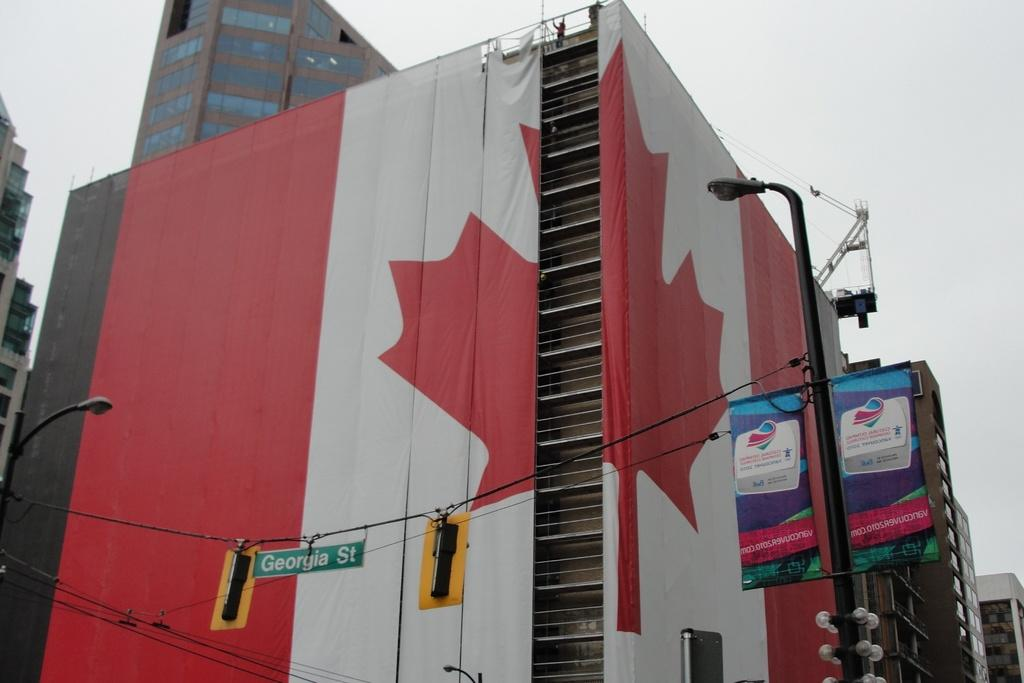<image>
Summarize the visual content of the image. a building behind street lights of georgia st 